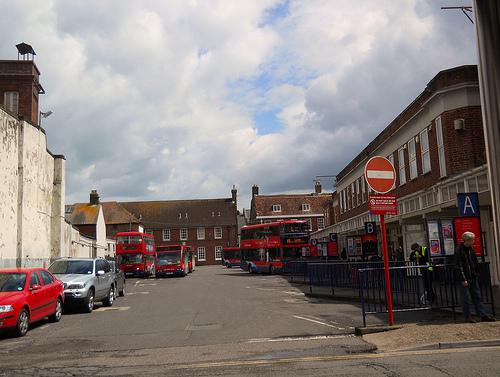Question: what is in the middle of the road?
Choices:
A. A motorcycle.
B. A person.
C. An animal.
D. A bus.
Answer with the letter. Answer: D Question: what color are the square lettered signs?
Choices:
A. Black.
B. Red.
C. White.
D. Blue.
Answer with the letter. Answer: D Question: what is in the sky?
Choices:
A. Clouds.
B. Planes.
C. Birds.
D. Balloons.
Answer with the letter. Answer: A 